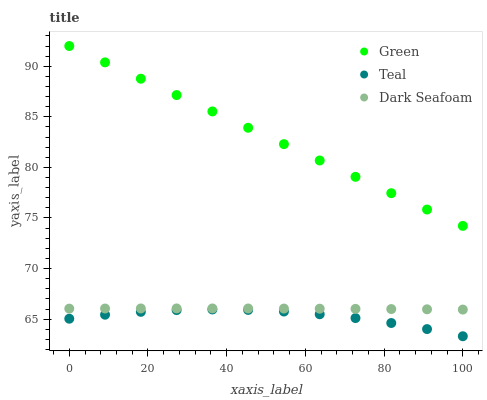Does Teal have the minimum area under the curve?
Answer yes or no. Yes. Does Green have the maximum area under the curve?
Answer yes or no. Yes. Does Green have the minimum area under the curve?
Answer yes or no. No. Does Teal have the maximum area under the curve?
Answer yes or no. No. Is Green the smoothest?
Answer yes or no. Yes. Is Teal the roughest?
Answer yes or no. Yes. Is Teal the smoothest?
Answer yes or no. No. Is Green the roughest?
Answer yes or no. No. Does Teal have the lowest value?
Answer yes or no. Yes. Does Green have the lowest value?
Answer yes or no. No. Does Green have the highest value?
Answer yes or no. Yes. Does Teal have the highest value?
Answer yes or no. No. Is Teal less than Dark Seafoam?
Answer yes or no. Yes. Is Green greater than Teal?
Answer yes or no. Yes. Does Teal intersect Dark Seafoam?
Answer yes or no. No. 